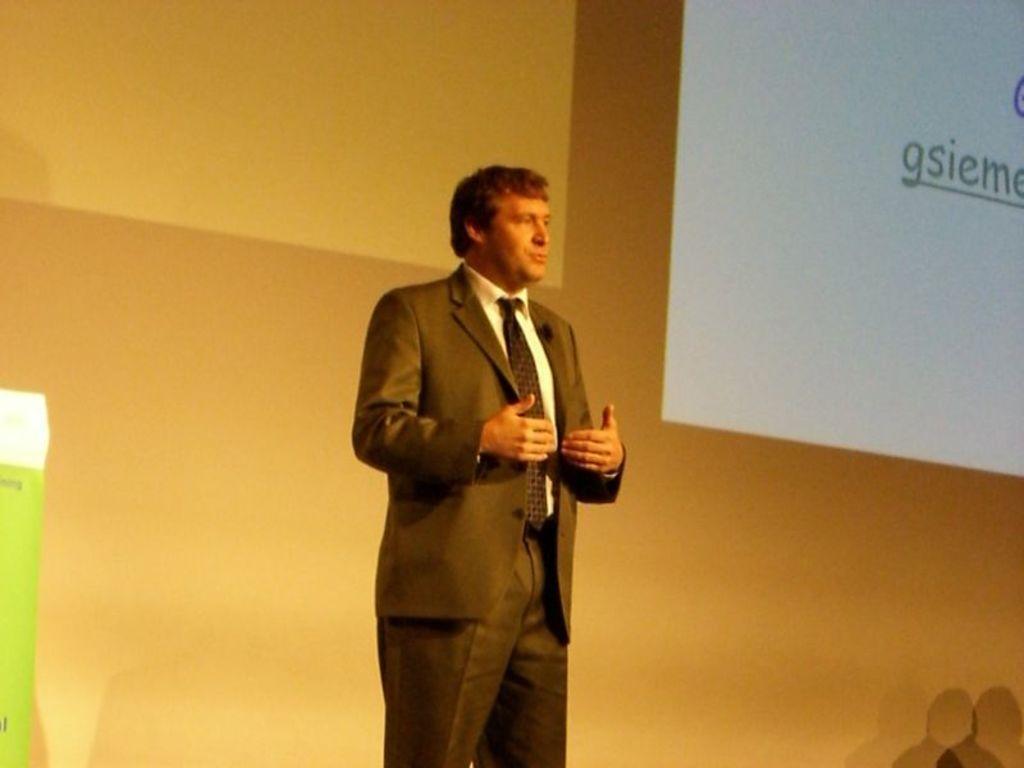Please provide a concise description of this image. In the image we can see a man standing and wearing clothes. Here we can see projected screen and the wall. 